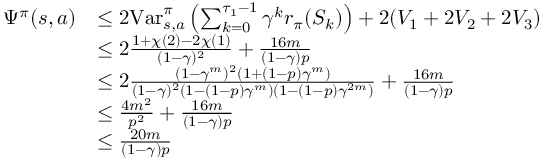<formula> <loc_0><loc_0><loc_500><loc_500>\begin{array} { r l } { \Psi ^ { \pi } ( s , a ) } & { \leq 2 V a r _ { s , a } ^ { \pi } \left ( \sum _ { k = 0 } ^ { \tau _ { 1 } - 1 } \gamma ^ { k } r _ { \pi } ( S _ { k } ) \right ) + 2 ( V _ { 1 } + 2 V _ { 2 } + 2 V _ { 3 } ) } \\ & { \leq 2 \frac { 1 + \chi ( 2 ) - 2 \chi ( 1 ) } { ( 1 - \gamma ) ^ { 2 } } + \frac { 1 6 m } { ( 1 - \gamma ) p } } \\ & { \leq 2 \frac { ( 1 - \gamma ^ { m } ) ^ { 2 } ( 1 + ( 1 - p ) \gamma ^ { m } ) } { ( 1 - \gamma ) ^ { 2 } ( 1 - ( 1 - p ) \gamma ^ { m } ) ( 1 - ( 1 - p ) \gamma ^ { 2 m } ) } + \frac { 1 6 m } { ( 1 - \gamma ) p } } \\ & { \leq \frac { 4 m ^ { 2 } } { p ^ { 2 } } + \frac { 1 6 m } { ( 1 - \gamma ) p } } \\ & { \leq \frac { 2 0 m } { ( 1 - \gamma ) p } } \end{array}</formula> 